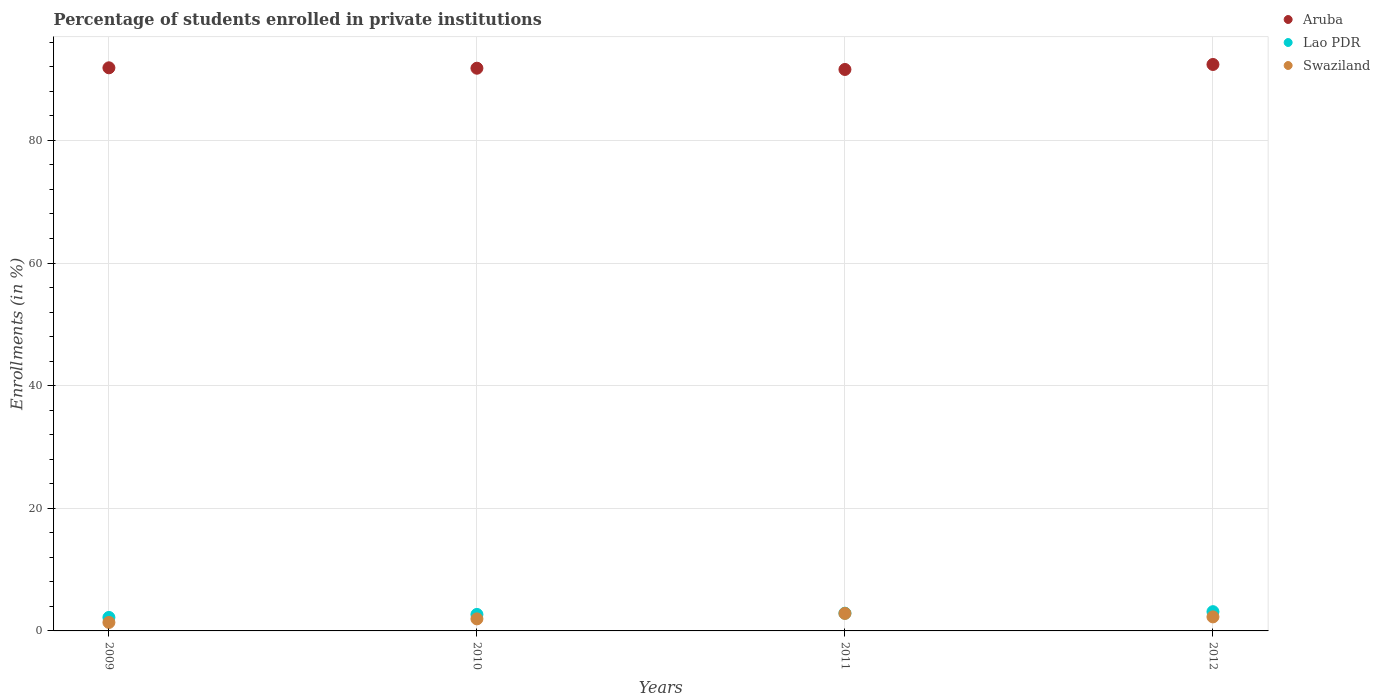Is the number of dotlines equal to the number of legend labels?
Give a very brief answer. Yes. What is the percentage of trained teachers in Aruba in 2010?
Keep it short and to the point. 91.77. Across all years, what is the maximum percentage of trained teachers in Aruba?
Your answer should be compact. 92.38. Across all years, what is the minimum percentage of trained teachers in Aruba?
Give a very brief answer. 91.57. In which year was the percentage of trained teachers in Lao PDR maximum?
Make the answer very short. 2012. What is the total percentage of trained teachers in Aruba in the graph?
Your answer should be very brief. 367.57. What is the difference between the percentage of trained teachers in Lao PDR in 2009 and that in 2011?
Ensure brevity in your answer.  -0.69. What is the difference between the percentage of trained teachers in Swaziland in 2011 and the percentage of trained teachers in Aruba in 2010?
Provide a short and direct response. -88.92. What is the average percentage of trained teachers in Swaziland per year?
Your answer should be very brief. 2.12. In the year 2011, what is the difference between the percentage of trained teachers in Lao PDR and percentage of trained teachers in Aruba?
Your answer should be compact. -88.68. What is the ratio of the percentage of trained teachers in Swaziland in 2009 to that in 2011?
Your response must be concise. 0.48. What is the difference between the highest and the second highest percentage of trained teachers in Swaziland?
Your response must be concise. 0.56. What is the difference between the highest and the lowest percentage of trained teachers in Swaziland?
Your answer should be compact. 1.47. In how many years, is the percentage of trained teachers in Aruba greater than the average percentage of trained teachers in Aruba taken over all years?
Your answer should be very brief. 1. Is the sum of the percentage of trained teachers in Swaziland in 2010 and 2012 greater than the maximum percentage of trained teachers in Lao PDR across all years?
Ensure brevity in your answer.  Yes. Is it the case that in every year, the sum of the percentage of trained teachers in Aruba and percentage of trained teachers in Swaziland  is greater than the percentage of trained teachers in Lao PDR?
Give a very brief answer. Yes. Is the percentage of trained teachers in Swaziland strictly greater than the percentage of trained teachers in Lao PDR over the years?
Give a very brief answer. No. What is the difference between two consecutive major ticks on the Y-axis?
Offer a terse response. 20. Are the values on the major ticks of Y-axis written in scientific E-notation?
Provide a short and direct response. No. Does the graph contain any zero values?
Offer a very short reply. No. How many legend labels are there?
Offer a very short reply. 3. How are the legend labels stacked?
Ensure brevity in your answer.  Vertical. What is the title of the graph?
Your answer should be very brief. Percentage of students enrolled in private institutions. What is the label or title of the X-axis?
Your response must be concise. Years. What is the label or title of the Y-axis?
Your response must be concise. Enrollments (in %). What is the Enrollments (in %) of Aruba in 2009?
Make the answer very short. 91.84. What is the Enrollments (in %) of Lao PDR in 2009?
Your answer should be compact. 2.2. What is the Enrollments (in %) in Swaziland in 2009?
Offer a terse response. 1.38. What is the Enrollments (in %) of Aruba in 2010?
Keep it short and to the point. 91.77. What is the Enrollments (in %) of Lao PDR in 2010?
Your answer should be very brief. 2.69. What is the Enrollments (in %) of Swaziland in 2010?
Give a very brief answer. 1.96. What is the Enrollments (in %) of Aruba in 2011?
Provide a succinct answer. 91.57. What is the Enrollments (in %) of Lao PDR in 2011?
Your answer should be compact. 2.89. What is the Enrollments (in %) in Swaziland in 2011?
Offer a very short reply. 2.85. What is the Enrollments (in %) in Aruba in 2012?
Make the answer very short. 92.38. What is the Enrollments (in %) of Lao PDR in 2012?
Offer a very short reply. 3.14. What is the Enrollments (in %) of Swaziland in 2012?
Provide a succinct answer. 2.29. Across all years, what is the maximum Enrollments (in %) of Aruba?
Give a very brief answer. 92.38. Across all years, what is the maximum Enrollments (in %) in Lao PDR?
Your response must be concise. 3.14. Across all years, what is the maximum Enrollments (in %) of Swaziland?
Keep it short and to the point. 2.85. Across all years, what is the minimum Enrollments (in %) of Aruba?
Your answer should be compact. 91.57. Across all years, what is the minimum Enrollments (in %) of Lao PDR?
Offer a very short reply. 2.2. Across all years, what is the minimum Enrollments (in %) in Swaziland?
Your answer should be compact. 1.38. What is the total Enrollments (in %) of Aruba in the graph?
Your answer should be compact. 367.57. What is the total Enrollments (in %) of Lao PDR in the graph?
Offer a very short reply. 10.92. What is the total Enrollments (in %) of Swaziland in the graph?
Provide a short and direct response. 8.49. What is the difference between the Enrollments (in %) in Aruba in 2009 and that in 2010?
Provide a succinct answer. 0.07. What is the difference between the Enrollments (in %) of Lao PDR in 2009 and that in 2010?
Your answer should be compact. -0.49. What is the difference between the Enrollments (in %) in Swaziland in 2009 and that in 2010?
Offer a very short reply. -0.58. What is the difference between the Enrollments (in %) of Aruba in 2009 and that in 2011?
Give a very brief answer. 0.27. What is the difference between the Enrollments (in %) in Lao PDR in 2009 and that in 2011?
Your answer should be compact. -0.69. What is the difference between the Enrollments (in %) of Swaziland in 2009 and that in 2011?
Keep it short and to the point. -1.47. What is the difference between the Enrollments (in %) in Aruba in 2009 and that in 2012?
Offer a very short reply. -0.54. What is the difference between the Enrollments (in %) of Lao PDR in 2009 and that in 2012?
Make the answer very short. -0.94. What is the difference between the Enrollments (in %) of Swaziland in 2009 and that in 2012?
Your response must be concise. -0.91. What is the difference between the Enrollments (in %) of Aruba in 2010 and that in 2011?
Give a very brief answer. 0.2. What is the difference between the Enrollments (in %) of Swaziland in 2010 and that in 2011?
Provide a short and direct response. -0.89. What is the difference between the Enrollments (in %) of Aruba in 2010 and that in 2012?
Provide a short and direct response. -0.61. What is the difference between the Enrollments (in %) of Lao PDR in 2010 and that in 2012?
Your answer should be very brief. -0.45. What is the difference between the Enrollments (in %) in Swaziland in 2010 and that in 2012?
Your answer should be very brief. -0.32. What is the difference between the Enrollments (in %) in Aruba in 2011 and that in 2012?
Offer a very short reply. -0.81. What is the difference between the Enrollments (in %) of Lao PDR in 2011 and that in 2012?
Provide a succinct answer. -0.25. What is the difference between the Enrollments (in %) of Swaziland in 2011 and that in 2012?
Ensure brevity in your answer.  0.56. What is the difference between the Enrollments (in %) of Aruba in 2009 and the Enrollments (in %) of Lao PDR in 2010?
Offer a very short reply. 89.15. What is the difference between the Enrollments (in %) of Aruba in 2009 and the Enrollments (in %) of Swaziland in 2010?
Your response must be concise. 89.88. What is the difference between the Enrollments (in %) of Lao PDR in 2009 and the Enrollments (in %) of Swaziland in 2010?
Your answer should be compact. 0.24. What is the difference between the Enrollments (in %) in Aruba in 2009 and the Enrollments (in %) in Lao PDR in 2011?
Provide a short and direct response. 88.95. What is the difference between the Enrollments (in %) in Aruba in 2009 and the Enrollments (in %) in Swaziland in 2011?
Provide a succinct answer. 88.99. What is the difference between the Enrollments (in %) in Lao PDR in 2009 and the Enrollments (in %) in Swaziland in 2011?
Your response must be concise. -0.65. What is the difference between the Enrollments (in %) of Aruba in 2009 and the Enrollments (in %) of Lao PDR in 2012?
Your answer should be compact. 88.7. What is the difference between the Enrollments (in %) in Aruba in 2009 and the Enrollments (in %) in Swaziland in 2012?
Provide a succinct answer. 89.55. What is the difference between the Enrollments (in %) in Lao PDR in 2009 and the Enrollments (in %) in Swaziland in 2012?
Offer a very short reply. -0.09. What is the difference between the Enrollments (in %) in Aruba in 2010 and the Enrollments (in %) in Lao PDR in 2011?
Give a very brief answer. 88.88. What is the difference between the Enrollments (in %) of Aruba in 2010 and the Enrollments (in %) of Swaziland in 2011?
Your answer should be very brief. 88.92. What is the difference between the Enrollments (in %) of Lao PDR in 2010 and the Enrollments (in %) of Swaziland in 2011?
Keep it short and to the point. -0.16. What is the difference between the Enrollments (in %) in Aruba in 2010 and the Enrollments (in %) in Lao PDR in 2012?
Keep it short and to the point. 88.63. What is the difference between the Enrollments (in %) in Aruba in 2010 and the Enrollments (in %) in Swaziland in 2012?
Keep it short and to the point. 89.49. What is the difference between the Enrollments (in %) in Lao PDR in 2010 and the Enrollments (in %) in Swaziland in 2012?
Your answer should be very brief. 0.4. What is the difference between the Enrollments (in %) in Aruba in 2011 and the Enrollments (in %) in Lao PDR in 2012?
Your answer should be compact. 88.43. What is the difference between the Enrollments (in %) in Aruba in 2011 and the Enrollments (in %) in Swaziland in 2012?
Keep it short and to the point. 89.28. What is the difference between the Enrollments (in %) in Lao PDR in 2011 and the Enrollments (in %) in Swaziland in 2012?
Your answer should be compact. 0.6. What is the average Enrollments (in %) in Aruba per year?
Your response must be concise. 91.89. What is the average Enrollments (in %) of Lao PDR per year?
Offer a terse response. 2.73. What is the average Enrollments (in %) of Swaziland per year?
Provide a short and direct response. 2.12. In the year 2009, what is the difference between the Enrollments (in %) of Aruba and Enrollments (in %) of Lao PDR?
Make the answer very short. 89.64. In the year 2009, what is the difference between the Enrollments (in %) in Aruba and Enrollments (in %) in Swaziland?
Provide a succinct answer. 90.46. In the year 2009, what is the difference between the Enrollments (in %) of Lao PDR and Enrollments (in %) of Swaziland?
Your answer should be compact. 0.82. In the year 2010, what is the difference between the Enrollments (in %) of Aruba and Enrollments (in %) of Lao PDR?
Keep it short and to the point. 89.08. In the year 2010, what is the difference between the Enrollments (in %) in Aruba and Enrollments (in %) in Swaziland?
Provide a succinct answer. 89.81. In the year 2010, what is the difference between the Enrollments (in %) of Lao PDR and Enrollments (in %) of Swaziland?
Your answer should be very brief. 0.73. In the year 2011, what is the difference between the Enrollments (in %) in Aruba and Enrollments (in %) in Lao PDR?
Offer a terse response. 88.68. In the year 2011, what is the difference between the Enrollments (in %) of Aruba and Enrollments (in %) of Swaziland?
Offer a terse response. 88.72. In the year 2011, what is the difference between the Enrollments (in %) of Lao PDR and Enrollments (in %) of Swaziland?
Your response must be concise. 0.04. In the year 2012, what is the difference between the Enrollments (in %) in Aruba and Enrollments (in %) in Lao PDR?
Your response must be concise. 89.24. In the year 2012, what is the difference between the Enrollments (in %) in Aruba and Enrollments (in %) in Swaziland?
Your answer should be very brief. 90.1. In the year 2012, what is the difference between the Enrollments (in %) in Lao PDR and Enrollments (in %) in Swaziland?
Ensure brevity in your answer.  0.85. What is the ratio of the Enrollments (in %) of Lao PDR in 2009 to that in 2010?
Offer a very short reply. 0.82. What is the ratio of the Enrollments (in %) in Swaziland in 2009 to that in 2010?
Keep it short and to the point. 0.7. What is the ratio of the Enrollments (in %) in Aruba in 2009 to that in 2011?
Give a very brief answer. 1. What is the ratio of the Enrollments (in %) in Lao PDR in 2009 to that in 2011?
Provide a succinct answer. 0.76. What is the ratio of the Enrollments (in %) of Swaziland in 2009 to that in 2011?
Your answer should be compact. 0.48. What is the ratio of the Enrollments (in %) in Lao PDR in 2009 to that in 2012?
Provide a short and direct response. 0.7. What is the ratio of the Enrollments (in %) in Swaziland in 2009 to that in 2012?
Ensure brevity in your answer.  0.6. What is the ratio of the Enrollments (in %) of Lao PDR in 2010 to that in 2011?
Keep it short and to the point. 0.93. What is the ratio of the Enrollments (in %) in Swaziland in 2010 to that in 2011?
Offer a very short reply. 0.69. What is the ratio of the Enrollments (in %) in Lao PDR in 2010 to that in 2012?
Your answer should be compact. 0.86. What is the ratio of the Enrollments (in %) of Swaziland in 2010 to that in 2012?
Give a very brief answer. 0.86. What is the ratio of the Enrollments (in %) in Lao PDR in 2011 to that in 2012?
Give a very brief answer. 0.92. What is the ratio of the Enrollments (in %) in Swaziland in 2011 to that in 2012?
Keep it short and to the point. 1.25. What is the difference between the highest and the second highest Enrollments (in %) in Aruba?
Offer a very short reply. 0.54. What is the difference between the highest and the second highest Enrollments (in %) of Lao PDR?
Make the answer very short. 0.25. What is the difference between the highest and the second highest Enrollments (in %) in Swaziland?
Offer a very short reply. 0.56. What is the difference between the highest and the lowest Enrollments (in %) in Aruba?
Provide a short and direct response. 0.81. What is the difference between the highest and the lowest Enrollments (in %) in Lao PDR?
Your answer should be very brief. 0.94. What is the difference between the highest and the lowest Enrollments (in %) in Swaziland?
Offer a terse response. 1.47. 